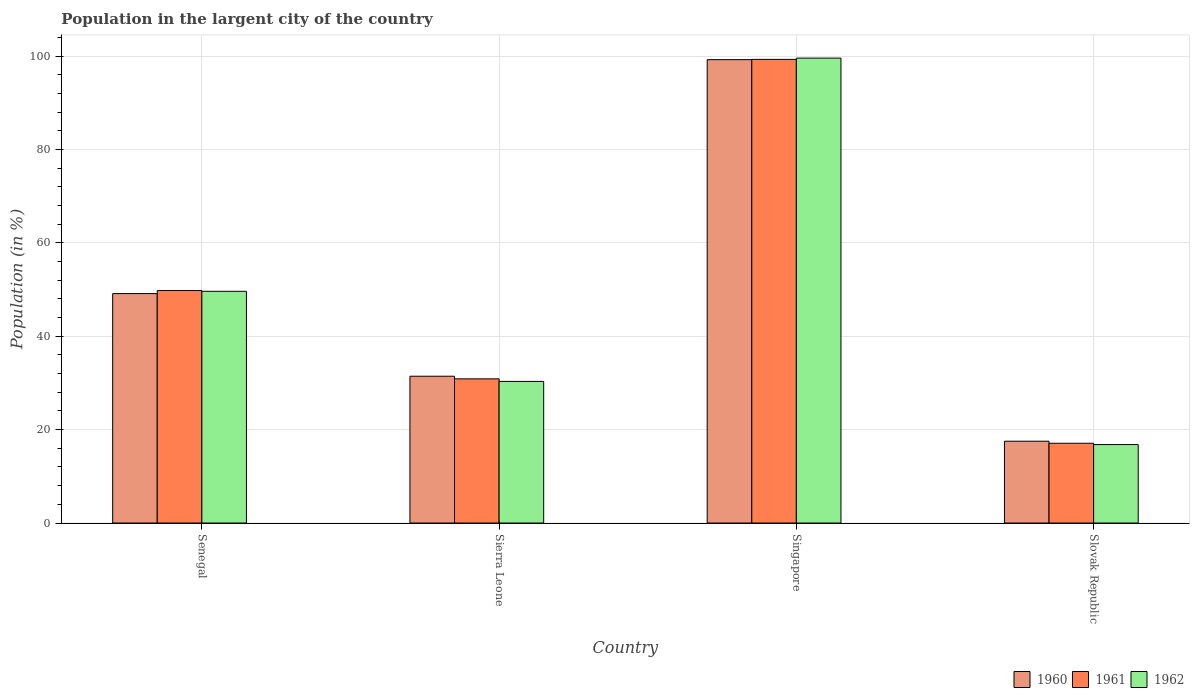How many different coloured bars are there?
Make the answer very short. 3. Are the number of bars per tick equal to the number of legend labels?
Provide a short and direct response. Yes. What is the label of the 4th group of bars from the left?
Provide a short and direct response. Slovak Republic. In how many cases, is the number of bars for a given country not equal to the number of legend labels?
Provide a succinct answer. 0. What is the percentage of population in the largent city in 1960 in Sierra Leone?
Your answer should be very brief. 31.44. Across all countries, what is the maximum percentage of population in the largent city in 1960?
Give a very brief answer. 99.23. Across all countries, what is the minimum percentage of population in the largent city in 1962?
Give a very brief answer. 16.8. In which country was the percentage of population in the largent city in 1961 maximum?
Provide a short and direct response. Singapore. In which country was the percentage of population in the largent city in 1960 minimum?
Your answer should be compact. Slovak Republic. What is the total percentage of population in the largent city in 1961 in the graph?
Keep it short and to the point. 197.04. What is the difference between the percentage of population in the largent city in 1960 in Singapore and that in Slovak Republic?
Your answer should be very brief. 81.71. What is the difference between the percentage of population in the largent city in 1960 in Singapore and the percentage of population in the largent city in 1961 in Senegal?
Provide a succinct answer. 49.44. What is the average percentage of population in the largent city in 1962 per country?
Make the answer very short. 49.08. What is the difference between the percentage of population in the largent city of/in 1962 and percentage of population in the largent city of/in 1961 in Senegal?
Offer a very short reply. -0.16. In how many countries, is the percentage of population in the largent city in 1962 greater than 24 %?
Provide a short and direct response. 3. What is the ratio of the percentage of population in the largent city in 1962 in Senegal to that in Singapore?
Make the answer very short. 0.5. Is the percentage of population in the largent city in 1961 in Senegal less than that in Singapore?
Provide a short and direct response. Yes. Is the difference between the percentage of population in the largent city in 1962 in Sierra Leone and Slovak Republic greater than the difference between the percentage of population in the largent city in 1961 in Sierra Leone and Slovak Republic?
Provide a succinct answer. No. What is the difference between the highest and the second highest percentage of population in the largent city in 1961?
Ensure brevity in your answer.  -49.51. What is the difference between the highest and the lowest percentage of population in the largent city in 1960?
Offer a terse response. 81.71. In how many countries, is the percentage of population in the largent city in 1961 greater than the average percentage of population in the largent city in 1961 taken over all countries?
Provide a succinct answer. 2. Is the sum of the percentage of population in the largent city in 1962 in Senegal and Singapore greater than the maximum percentage of population in the largent city in 1960 across all countries?
Offer a terse response. Yes. What does the 1st bar from the left in Senegal represents?
Offer a very short reply. 1960. Are all the bars in the graph horizontal?
Your answer should be very brief. No. How many countries are there in the graph?
Offer a terse response. 4. Are the values on the major ticks of Y-axis written in scientific E-notation?
Offer a very short reply. No. Does the graph contain any zero values?
Ensure brevity in your answer.  No. Does the graph contain grids?
Offer a very short reply. Yes. Where does the legend appear in the graph?
Your response must be concise. Bottom right. What is the title of the graph?
Offer a very short reply. Population in the largent city of the country. Does "1998" appear as one of the legend labels in the graph?
Provide a short and direct response. No. What is the label or title of the X-axis?
Your answer should be compact. Country. What is the label or title of the Y-axis?
Provide a succinct answer. Population (in %). What is the Population (in %) of 1960 in Senegal?
Offer a very short reply. 49.13. What is the Population (in %) of 1961 in Senegal?
Offer a very short reply. 49.79. What is the Population (in %) in 1962 in Senegal?
Offer a terse response. 49.62. What is the Population (in %) of 1960 in Sierra Leone?
Provide a short and direct response. 31.44. What is the Population (in %) of 1961 in Sierra Leone?
Make the answer very short. 30.88. What is the Population (in %) of 1962 in Sierra Leone?
Keep it short and to the point. 30.33. What is the Population (in %) in 1960 in Singapore?
Your response must be concise. 99.23. What is the Population (in %) in 1961 in Singapore?
Keep it short and to the point. 99.29. What is the Population (in %) in 1962 in Singapore?
Your answer should be very brief. 99.56. What is the Population (in %) of 1960 in Slovak Republic?
Give a very brief answer. 17.52. What is the Population (in %) of 1961 in Slovak Republic?
Provide a succinct answer. 17.08. What is the Population (in %) of 1962 in Slovak Republic?
Offer a very short reply. 16.8. Across all countries, what is the maximum Population (in %) of 1960?
Give a very brief answer. 99.23. Across all countries, what is the maximum Population (in %) in 1961?
Make the answer very short. 99.29. Across all countries, what is the maximum Population (in %) of 1962?
Keep it short and to the point. 99.56. Across all countries, what is the minimum Population (in %) of 1960?
Offer a terse response. 17.52. Across all countries, what is the minimum Population (in %) of 1961?
Give a very brief answer. 17.08. Across all countries, what is the minimum Population (in %) in 1962?
Keep it short and to the point. 16.8. What is the total Population (in %) of 1960 in the graph?
Ensure brevity in your answer.  197.32. What is the total Population (in %) of 1961 in the graph?
Offer a very short reply. 197.04. What is the total Population (in %) in 1962 in the graph?
Ensure brevity in your answer.  196.31. What is the difference between the Population (in %) in 1960 in Senegal and that in Sierra Leone?
Provide a short and direct response. 17.7. What is the difference between the Population (in %) of 1961 in Senegal and that in Sierra Leone?
Your answer should be compact. 18.91. What is the difference between the Population (in %) in 1962 in Senegal and that in Sierra Leone?
Your answer should be very brief. 19.3. What is the difference between the Population (in %) of 1960 in Senegal and that in Singapore?
Provide a succinct answer. -50.09. What is the difference between the Population (in %) in 1961 in Senegal and that in Singapore?
Keep it short and to the point. -49.51. What is the difference between the Population (in %) in 1962 in Senegal and that in Singapore?
Offer a very short reply. -49.94. What is the difference between the Population (in %) of 1960 in Senegal and that in Slovak Republic?
Ensure brevity in your answer.  31.61. What is the difference between the Population (in %) in 1961 in Senegal and that in Slovak Republic?
Make the answer very short. 32.7. What is the difference between the Population (in %) of 1962 in Senegal and that in Slovak Republic?
Ensure brevity in your answer.  32.82. What is the difference between the Population (in %) of 1960 in Sierra Leone and that in Singapore?
Provide a succinct answer. -67.79. What is the difference between the Population (in %) in 1961 in Sierra Leone and that in Singapore?
Offer a very short reply. -68.42. What is the difference between the Population (in %) in 1962 in Sierra Leone and that in Singapore?
Offer a very short reply. -69.23. What is the difference between the Population (in %) in 1960 in Sierra Leone and that in Slovak Republic?
Provide a succinct answer. 13.92. What is the difference between the Population (in %) in 1961 in Sierra Leone and that in Slovak Republic?
Keep it short and to the point. 13.79. What is the difference between the Population (in %) of 1962 in Sierra Leone and that in Slovak Republic?
Provide a succinct answer. 13.53. What is the difference between the Population (in %) of 1960 in Singapore and that in Slovak Republic?
Provide a succinct answer. 81.71. What is the difference between the Population (in %) in 1961 in Singapore and that in Slovak Republic?
Ensure brevity in your answer.  82.21. What is the difference between the Population (in %) in 1962 in Singapore and that in Slovak Republic?
Provide a succinct answer. 82.76. What is the difference between the Population (in %) of 1960 in Senegal and the Population (in %) of 1961 in Sierra Leone?
Your answer should be compact. 18.26. What is the difference between the Population (in %) of 1960 in Senegal and the Population (in %) of 1962 in Sierra Leone?
Provide a short and direct response. 18.81. What is the difference between the Population (in %) of 1961 in Senegal and the Population (in %) of 1962 in Sierra Leone?
Offer a terse response. 19.46. What is the difference between the Population (in %) in 1960 in Senegal and the Population (in %) in 1961 in Singapore?
Provide a succinct answer. -50.16. What is the difference between the Population (in %) of 1960 in Senegal and the Population (in %) of 1962 in Singapore?
Keep it short and to the point. -50.42. What is the difference between the Population (in %) in 1961 in Senegal and the Population (in %) in 1962 in Singapore?
Provide a succinct answer. -49.77. What is the difference between the Population (in %) of 1960 in Senegal and the Population (in %) of 1961 in Slovak Republic?
Provide a succinct answer. 32.05. What is the difference between the Population (in %) in 1960 in Senegal and the Population (in %) in 1962 in Slovak Republic?
Keep it short and to the point. 32.33. What is the difference between the Population (in %) of 1961 in Senegal and the Population (in %) of 1962 in Slovak Republic?
Provide a short and direct response. 32.99. What is the difference between the Population (in %) of 1960 in Sierra Leone and the Population (in %) of 1961 in Singapore?
Your answer should be compact. -67.85. What is the difference between the Population (in %) of 1960 in Sierra Leone and the Population (in %) of 1962 in Singapore?
Keep it short and to the point. -68.12. What is the difference between the Population (in %) in 1961 in Sierra Leone and the Population (in %) in 1962 in Singapore?
Your answer should be compact. -68.68. What is the difference between the Population (in %) of 1960 in Sierra Leone and the Population (in %) of 1961 in Slovak Republic?
Your response must be concise. 14.36. What is the difference between the Population (in %) of 1960 in Sierra Leone and the Population (in %) of 1962 in Slovak Republic?
Provide a short and direct response. 14.64. What is the difference between the Population (in %) in 1961 in Sierra Leone and the Population (in %) in 1962 in Slovak Republic?
Your answer should be compact. 14.08. What is the difference between the Population (in %) in 1960 in Singapore and the Population (in %) in 1961 in Slovak Republic?
Ensure brevity in your answer.  82.15. What is the difference between the Population (in %) of 1960 in Singapore and the Population (in %) of 1962 in Slovak Republic?
Your answer should be compact. 82.43. What is the difference between the Population (in %) in 1961 in Singapore and the Population (in %) in 1962 in Slovak Republic?
Offer a terse response. 82.49. What is the average Population (in %) in 1960 per country?
Provide a short and direct response. 49.33. What is the average Population (in %) of 1961 per country?
Your response must be concise. 49.26. What is the average Population (in %) of 1962 per country?
Offer a very short reply. 49.08. What is the difference between the Population (in %) in 1960 and Population (in %) in 1961 in Senegal?
Offer a very short reply. -0.65. What is the difference between the Population (in %) of 1960 and Population (in %) of 1962 in Senegal?
Provide a short and direct response. -0.49. What is the difference between the Population (in %) of 1961 and Population (in %) of 1962 in Senegal?
Provide a succinct answer. 0.16. What is the difference between the Population (in %) in 1960 and Population (in %) in 1961 in Sierra Leone?
Offer a very short reply. 0.56. What is the difference between the Population (in %) in 1960 and Population (in %) in 1962 in Sierra Leone?
Provide a succinct answer. 1.11. What is the difference between the Population (in %) of 1961 and Population (in %) of 1962 in Sierra Leone?
Your answer should be very brief. 0.55. What is the difference between the Population (in %) of 1960 and Population (in %) of 1961 in Singapore?
Make the answer very short. -0.06. What is the difference between the Population (in %) in 1960 and Population (in %) in 1962 in Singapore?
Your answer should be compact. -0.33. What is the difference between the Population (in %) of 1961 and Population (in %) of 1962 in Singapore?
Your answer should be compact. -0.27. What is the difference between the Population (in %) in 1960 and Population (in %) in 1961 in Slovak Republic?
Offer a terse response. 0.44. What is the difference between the Population (in %) in 1960 and Population (in %) in 1962 in Slovak Republic?
Keep it short and to the point. 0.72. What is the difference between the Population (in %) in 1961 and Population (in %) in 1962 in Slovak Republic?
Offer a terse response. 0.28. What is the ratio of the Population (in %) of 1960 in Senegal to that in Sierra Leone?
Ensure brevity in your answer.  1.56. What is the ratio of the Population (in %) in 1961 in Senegal to that in Sierra Leone?
Your answer should be very brief. 1.61. What is the ratio of the Population (in %) in 1962 in Senegal to that in Sierra Leone?
Offer a very short reply. 1.64. What is the ratio of the Population (in %) of 1960 in Senegal to that in Singapore?
Your response must be concise. 0.5. What is the ratio of the Population (in %) of 1961 in Senegal to that in Singapore?
Your answer should be very brief. 0.5. What is the ratio of the Population (in %) in 1962 in Senegal to that in Singapore?
Your answer should be very brief. 0.5. What is the ratio of the Population (in %) of 1960 in Senegal to that in Slovak Republic?
Provide a short and direct response. 2.8. What is the ratio of the Population (in %) of 1961 in Senegal to that in Slovak Republic?
Keep it short and to the point. 2.91. What is the ratio of the Population (in %) in 1962 in Senegal to that in Slovak Republic?
Make the answer very short. 2.95. What is the ratio of the Population (in %) of 1960 in Sierra Leone to that in Singapore?
Ensure brevity in your answer.  0.32. What is the ratio of the Population (in %) of 1961 in Sierra Leone to that in Singapore?
Offer a terse response. 0.31. What is the ratio of the Population (in %) of 1962 in Sierra Leone to that in Singapore?
Your answer should be very brief. 0.3. What is the ratio of the Population (in %) in 1960 in Sierra Leone to that in Slovak Republic?
Provide a succinct answer. 1.79. What is the ratio of the Population (in %) in 1961 in Sierra Leone to that in Slovak Republic?
Ensure brevity in your answer.  1.81. What is the ratio of the Population (in %) in 1962 in Sierra Leone to that in Slovak Republic?
Make the answer very short. 1.81. What is the ratio of the Population (in %) of 1960 in Singapore to that in Slovak Republic?
Make the answer very short. 5.66. What is the ratio of the Population (in %) of 1961 in Singapore to that in Slovak Republic?
Keep it short and to the point. 5.81. What is the ratio of the Population (in %) of 1962 in Singapore to that in Slovak Republic?
Keep it short and to the point. 5.93. What is the difference between the highest and the second highest Population (in %) of 1960?
Make the answer very short. 50.09. What is the difference between the highest and the second highest Population (in %) in 1961?
Give a very brief answer. 49.51. What is the difference between the highest and the second highest Population (in %) in 1962?
Ensure brevity in your answer.  49.94. What is the difference between the highest and the lowest Population (in %) of 1960?
Your answer should be compact. 81.71. What is the difference between the highest and the lowest Population (in %) of 1961?
Provide a succinct answer. 82.21. What is the difference between the highest and the lowest Population (in %) in 1962?
Keep it short and to the point. 82.76. 